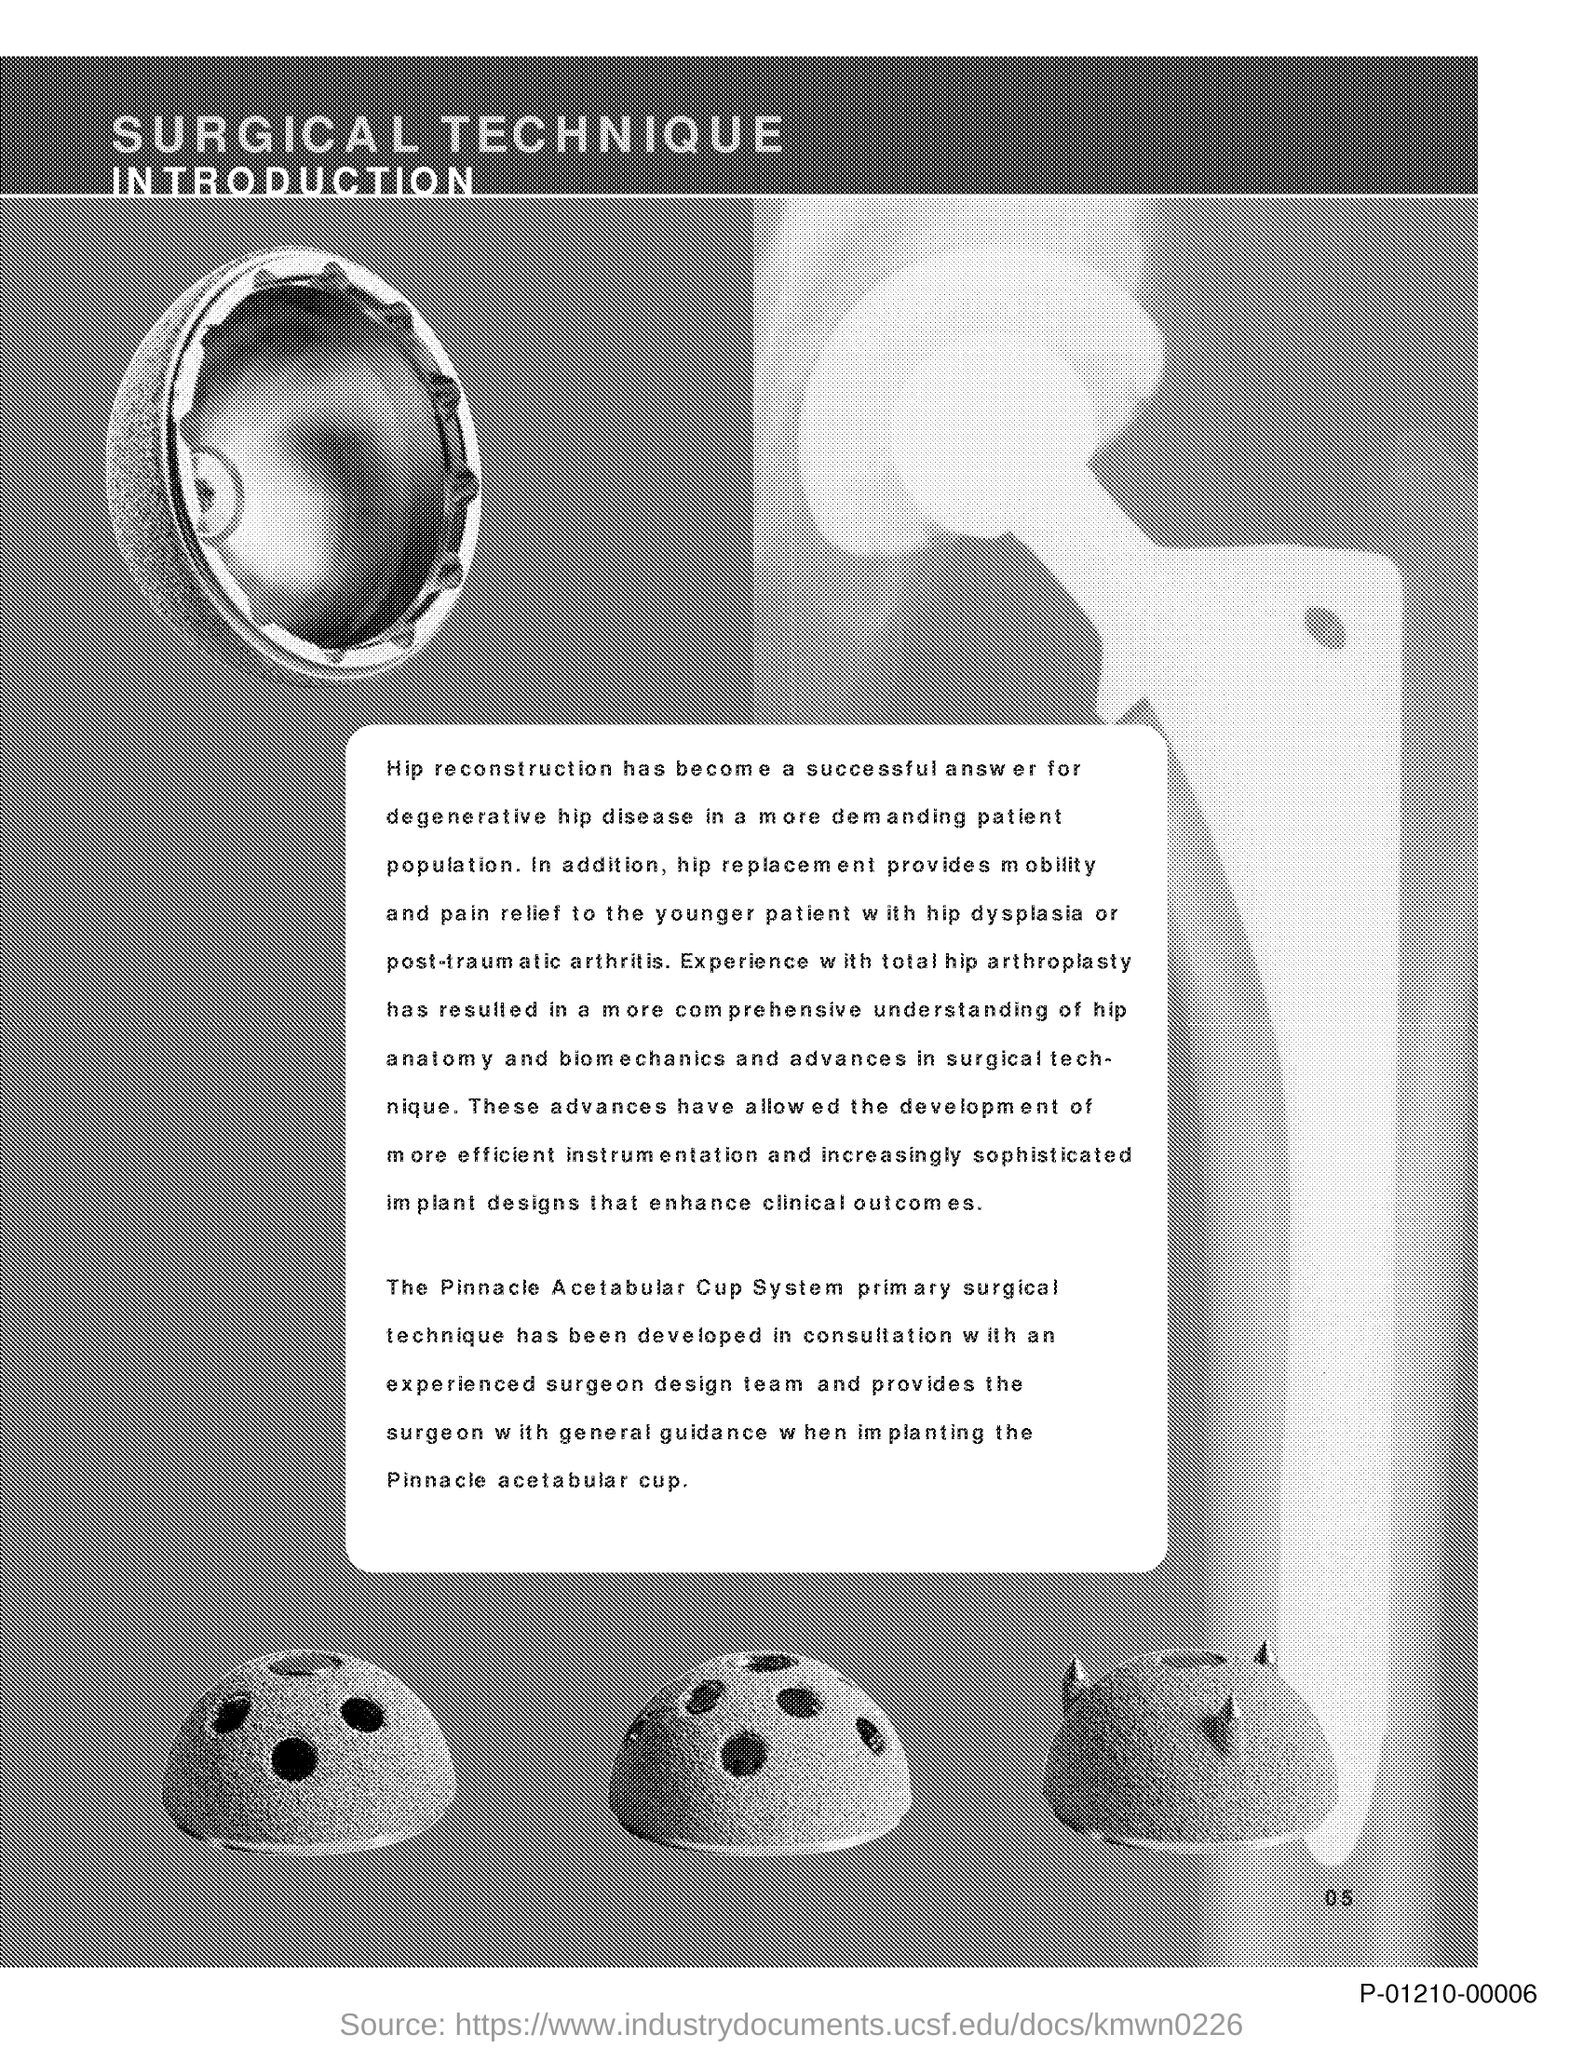Outline some significant characteristics in this image. The successful treatment option for degenerative hip disease is hip reconstruction. 